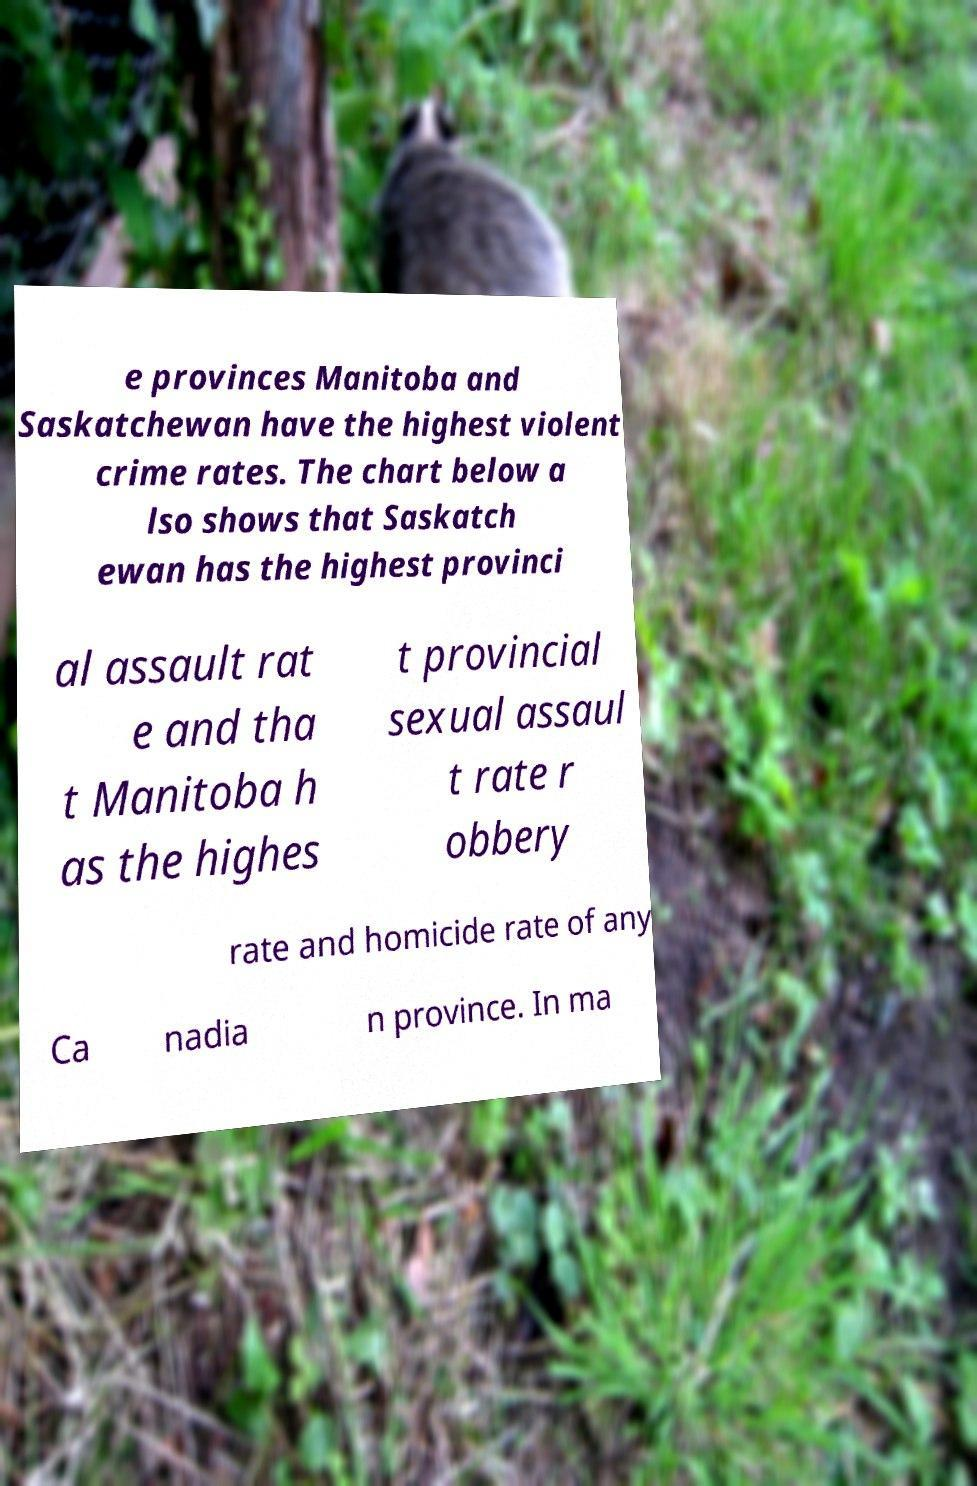Can you read and provide the text displayed in the image?This photo seems to have some interesting text. Can you extract and type it out for me? e provinces Manitoba and Saskatchewan have the highest violent crime rates. The chart below a lso shows that Saskatch ewan has the highest provinci al assault rat e and tha t Manitoba h as the highes t provincial sexual assaul t rate r obbery rate and homicide rate of any Ca nadia n province. In ma 